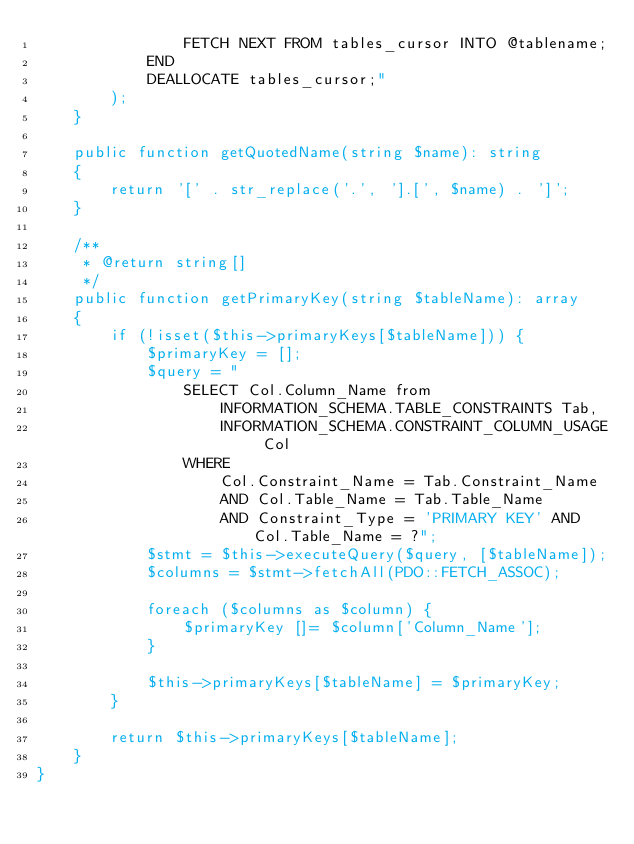<code> <loc_0><loc_0><loc_500><loc_500><_PHP_>                FETCH NEXT FROM tables_cursor INTO @tablename;
            END
            DEALLOCATE tables_cursor;"
        );
    }

    public function getQuotedName(string $name): string
    {
        return '[' . str_replace('.', '].[', $name) . ']';
    }

    /**
     * @return string[]
     */
    public function getPrimaryKey(string $tableName): array
    {
        if (!isset($this->primaryKeys[$tableName])) {
            $primaryKey = [];
            $query = "
                SELECT Col.Column_Name from
                    INFORMATION_SCHEMA.TABLE_CONSTRAINTS Tab,
                    INFORMATION_SCHEMA.CONSTRAINT_COLUMN_USAGE Col
                WHERE
                    Col.Constraint_Name = Tab.Constraint_Name
                    AND Col.Table_Name = Tab.Table_Name
                    AND Constraint_Type = 'PRIMARY KEY' AND Col.Table_Name = ?";
            $stmt = $this->executeQuery($query, [$tableName]);
            $columns = $stmt->fetchAll(PDO::FETCH_ASSOC);

            foreach ($columns as $column) {
                $primaryKey []= $column['Column_Name'];
            }

            $this->primaryKeys[$tableName] = $primaryKey;
        }

        return $this->primaryKeys[$tableName];
    }
}
</code> 